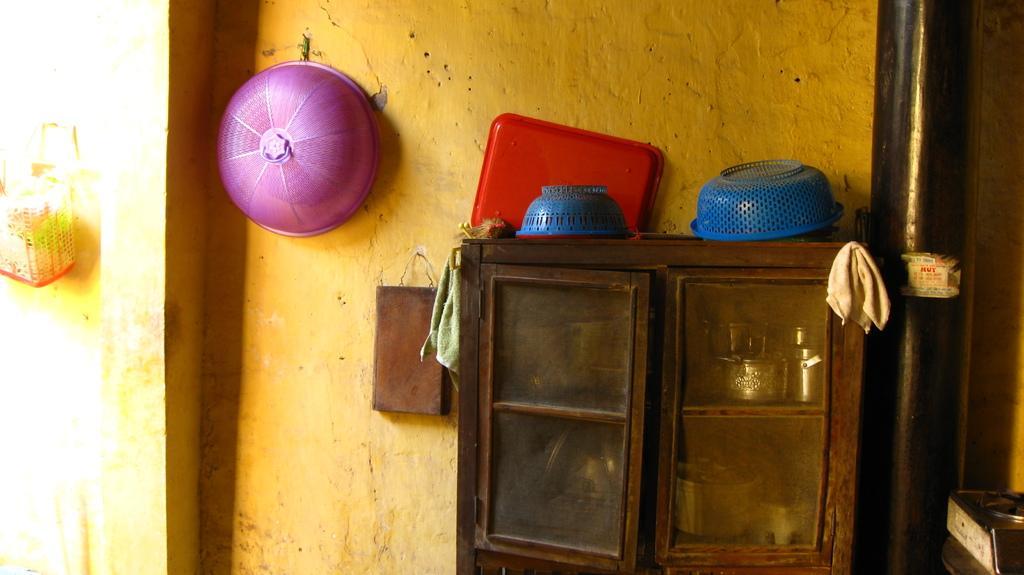Describe this image in one or two sentences. In this picture we can see few baskets, racks and a pipe on the wall. 